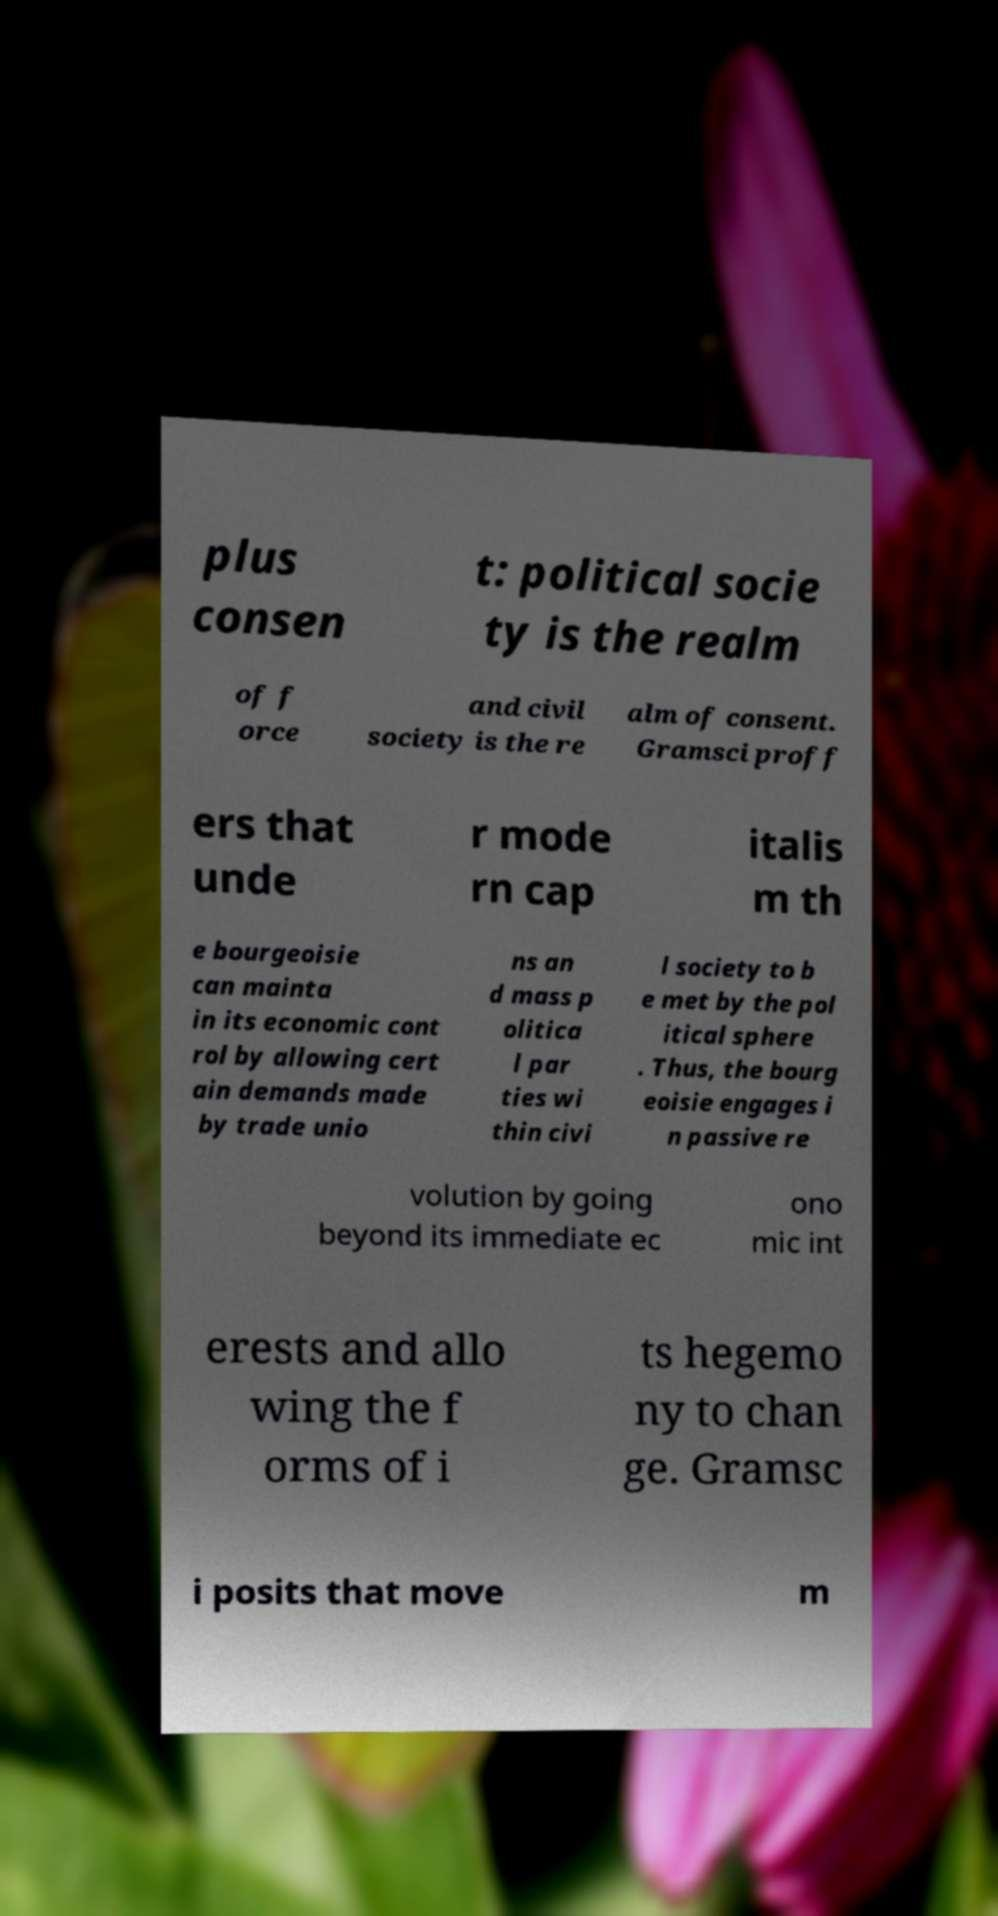What messages or text are displayed in this image? I need them in a readable, typed format. plus consen t: political socie ty is the realm of f orce and civil society is the re alm of consent. Gramsci proff ers that unde r mode rn cap italis m th e bourgeoisie can mainta in its economic cont rol by allowing cert ain demands made by trade unio ns an d mass p olitica l par ties wi thin civi l society to b e met by the pol itical sphere . Thus, the bourg eoisie engages i n passive re volution by going beyond its immediate ec ono mic int erests and allo wing the f orms of i ts hegemo ny to chan ge. Gramsc i posits that move m 